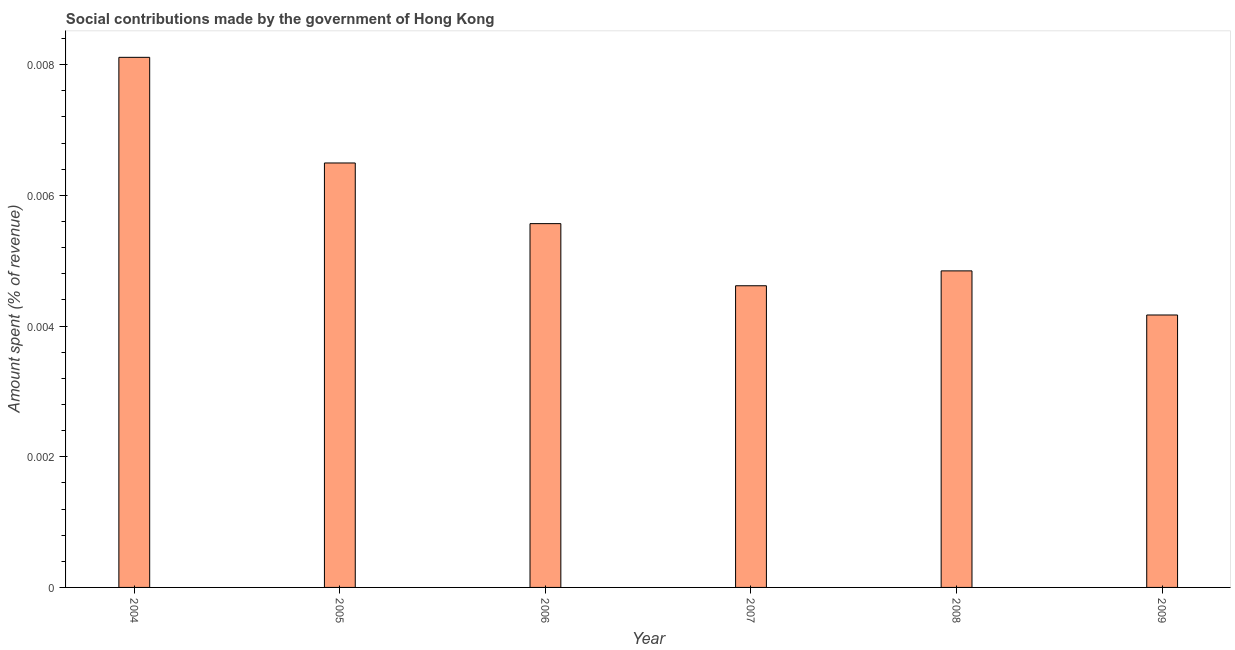Does the graph contain any zero values?
Provide a succinct answer. No. What is the title of the graph?
Ensure brevity in your answer.  Social contributions made by the government of Hong Kong. What is the label or title of the X-axis?
Provide a succinct answer. Year. What is the label or title of the Y-axis?
Your response must be concise. Amount spent (% of revenue). What is the amount spent in making social contributions in 2007?
Your answer should be compact. 0. Across all years, what is the maximum amount spent in making social contributions?
Offer a very short reply. 0.01. Across all years, what is the minimum amount spent in making social contributions?
Give a very brief answer. 0. What is the sum of the amount spent in making social contributions?
Ensure brevity in your answer.  0.03. What is the difference between the amount spent in making social contributions in 2006 and 2007?
Make the answer very short. 0. What is the average amount spent in making social contributions per year?
Your response must be concise. 0.01. What is the median amount spent in making social contributions?
Your answer should be compact. 0.01. In how many years, is the amount spent in making social contributions greater than 0.004 %?
Make the answer very short. 6. Do a majority of the years between 2009 and 2005 (inclusive) have amount spent in making social contributions greater than 0.0016 %?
Offer a terse response. Yes. What is the ratio of the amount spent in making social contributions in 2005 to that in 2008?
Ensure brevity in your answer.  1.34. Is the difference between the amount spent in making social contributions in 2005 and 2008 greater than the difference between any two years?
Offer a terse response. No. What is the difference between the highest and the second highest amount spent in making social contributions?
Give a very brief answer. 0. What is the difference between the highest and the lowest amount spent in making social contributions?
Keep it short and to the point. 0. In how many years, is the amount spent in making social contributions greater than the average amount spent in making social contributions taken over all years?
Your answer should be very brief. 2. How many bars are there?
Provide a short and direct response. 6. Are all the bars in the graph horizontal?
Keep it short and to the point. No. How many years are there in the graph?
Provide a short and direct response. 6. What is the difference between two consecutive major ticks on the Y-axis?
Provide a short and direct response. 0. Are the values on the major ticks of Y-axis written in scientific E-notation?
Keep it short and to the point. No. What is the Amount spent (% of revenue) in 2004?
Make the answer very short. 0.01. What is the Amount spent (% of revenue) of 2005?
Offer a very short reply. 0.01. What is the Amount spent (% of revenue) in 2006?
Give a very brief answer. 0.01. What is the Amount spent (% of revenue) in 2007?
Make the answer very short. 0. What is the Amount spent (% of revenue) of 2008?
Offer a very short reply. 0. What is the Amount spent (% of revenue) of 2009?
Make the answer very short. 0. What is the difference between the Amount spent (% of revenue) in 2004 and 2005?
Offer a terse response. 0. What is the difference between the Amount spent (% of revenue) in 2004 and 2006?
Keep it short and to the point. 0. What is the difference between the Amount spent (% of revenue) in 2004 and 2007?
Give a very brief answer. 0. What is the difference between the Amount spent (% of revenue) in 2004 and 2008?
Give a very brief answer. 0. What is the difference between the Amount spent (% of revenue) in 2004 and 2009?
Your response must be concise. 0. What is the difference between the Amount spent (% of revenue) in 2005 and 2006?
Provide a short and direct response. 0. What is the difference between the Amount spent (% of revenue) in 2005 and 2007?
Provide a short and direct response. 0. What is the difference between the Amount spent (% of revenue) in 2005 and 2008?
Offer a very short reply. 0. What is the difference between the Amount spent (% of revenue) in 2005 and 2009?
Give a very brief answer. 0. What is the difference between the Amount spent (% of revenue) in 2006 and 2007?
Make the answer very short. 0. What is the difference between the Amount spent (% of revenue) in 2006 and 2008?
Your answer should be very brief. 0. What is the difference between the Amount spent (% of revenue) in 2006 and 2009?
Keep it short and to the point. 0. What is the difference between the Amount spent (% of revenue) in 2007 and 2008?
Keep it short and to the point. -0. What is the difference between the Amount spent (% of revenue) in 2007 and 2009?
Your response must be concise. 0. What is the difference between the Amount spent (% of revenue) in 2008 and 2009?
Your response must be concise. 0. What is the ratio of the Amount spent (% of revenue) in 2004 to that in 2005?
Keep it short and to the point. 1.25. What is the ratio of the Amount spent (% of revenue) in 2004 to that in 2006?
Ensure brevity in your answer.  1.46. What is the ratio of the Amount spent (% of revenue) in 2004 to that in 2007?
Offer a terse response. 1.76. What is the ratio of the Amount spent (% of revenue) in 2004 to that in 2008?
Give a very brief answer. 1.68. What is the ratio of the Amount spent (% of revenue) in 2004 to that in 2009?
Make the answer very short. 1.95. What is the ratio of the Amount spent (% of revenue) in 2005 to that in 2006?
Ensure brevity in your answer.  1.17. What is the ratio of the Amount spent (% of revenue) in 2005 to that in 2007?
Give a very brief answer. 1.41. What is the ratio of the Amount spent (% of revenue) in 2005 to that in 2008?
Provide a short and direct response. 1.34. What is the ratio of the Amount spent (% of revenue) in 2005 to that in 2009?
Keep it short and to the point. 1.56. What is the ratio of the Amount spent (% of revenue) in 2006 to that in 2007?
Offer a very short reply. 1.21. What is the ratio of the Amount spent (% of revenue) in 2006 to that in 2008?
Provide a succinct answer. 1.15. What is the ratio of the Amount spent (% of revenue) in 2006 to that in 2009?
Offer a very short reply. 1.33. What is the ratio of the Amount spent (% of revenue) in 2007 to that in 2008?
Give a very brief answer. 0.95. What is the ratio of the Amount spent (% of revenue) in 2007 to that in 2009?
Make the answer very short. 1.11. What is the ratio of the Amount spent (% of revenue) in 2008 to that in 2009?
Keep it short and to the point. 1.16. 